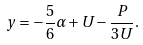<formula> <loc_0><loc_0><loc_500><loc_500>y = - \frac { 5 } { 6 } \alpha + U - \frac { P } { 3 U } .</formula> 